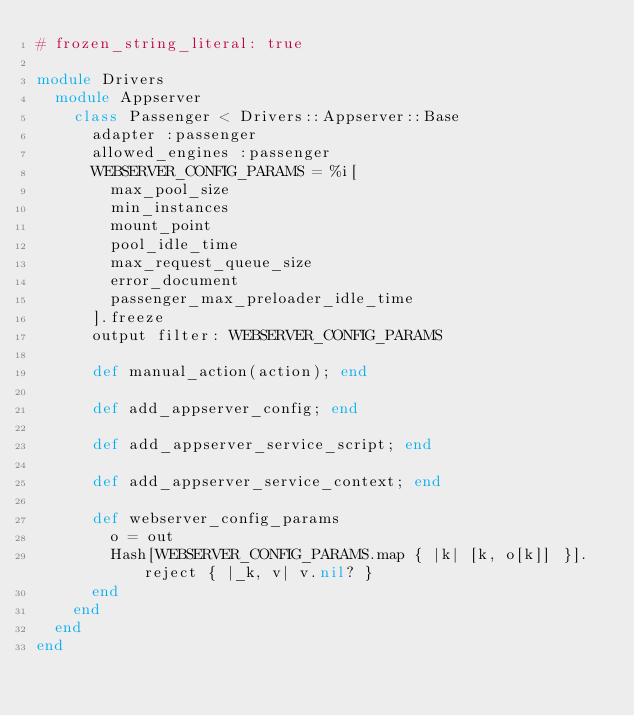<code> <loc_0><loc_0><loc_500><loc_500><_Ruby_># frozen_string_literal: true

module Drivers
  module Appserver
    class Passenger < Drivers::Appserver::Base
      adapter :passenger
      allowed_engines :passenger
      WEBSERVER_CONFIG_PARAMS = %i[
        max_pool_size
        min_instances
        mount_point
        pool_idle_time
        max_request_queue_size
        error_document
        passenger_max_preloader_idle_time
      ].freeze
      output filter: WEBSERVER_CONFIG_PARAMS

      def manual_action(action); end

      def add_appserver_config; end

      def add_appserver_service_script; end

      def add_appserver_service_context; end

      def webserver_config_params
        o = out
        Hash[WEBSERVER_CONFIG_PARAMS.map { |k| [k, o[k]] }].reject { |_k, v| v.nil? }
      end
    end
  end
end
</code> 